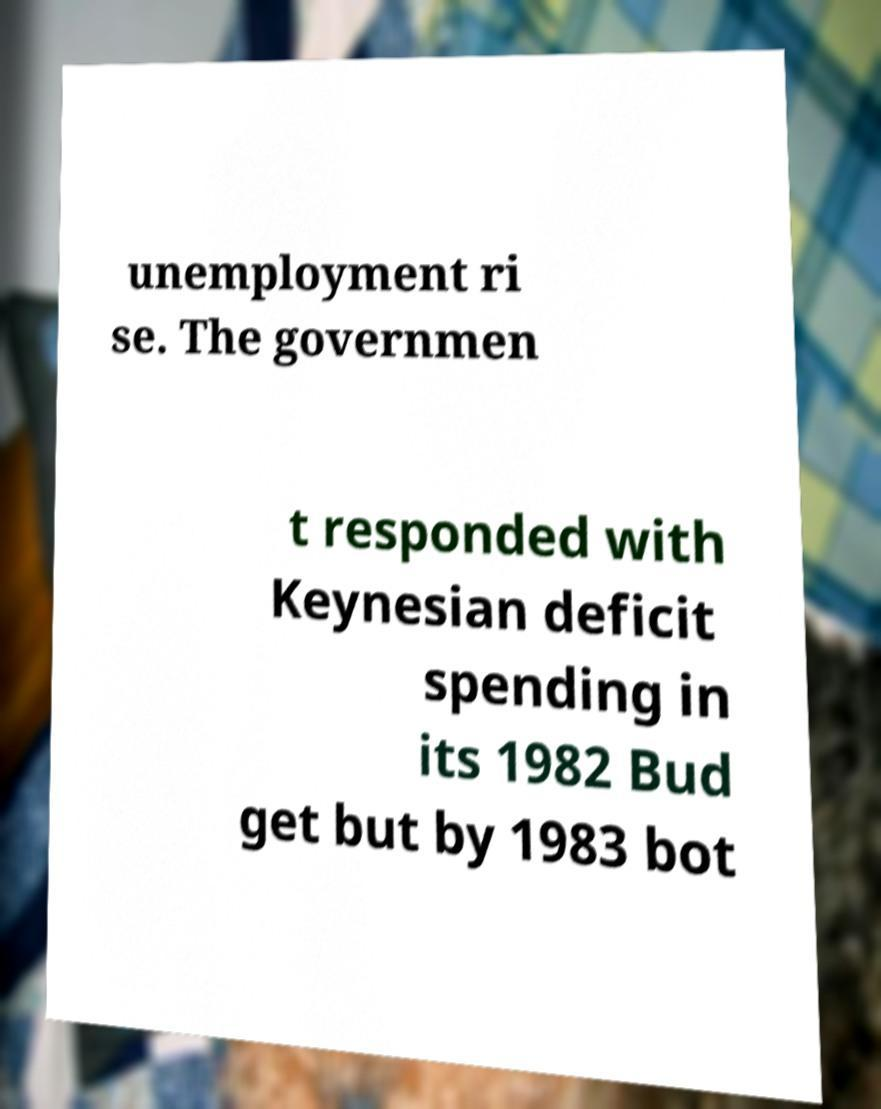There's text embedded in this image that I need extracted. Can you transcribe it verbatim? unemployment ri se. The governmen t responded with Keynesian deficit spending in its 1982 Bud get but by 1983 bot 